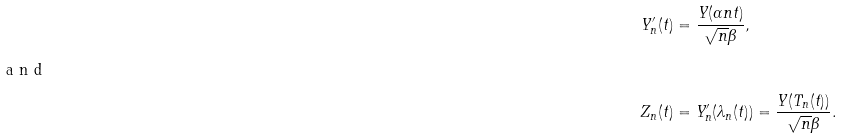<formula> <loc_0><loc_0><loc_500><loc_500>Y ^ { \prime } _ { n } ( t ) & = \frac { Y ( \alpha n t ) } { \sqrt { n } \beta } , \\ \intertext { a n d } Z _ { n } ( t ) & = Y ^ { \prime } _ { n } ( \lambda _ { n } ( t ) ) = \frac { Y ( T _ { n } ( t ) ) } { \sqrt { n } \beta } .</formula> 